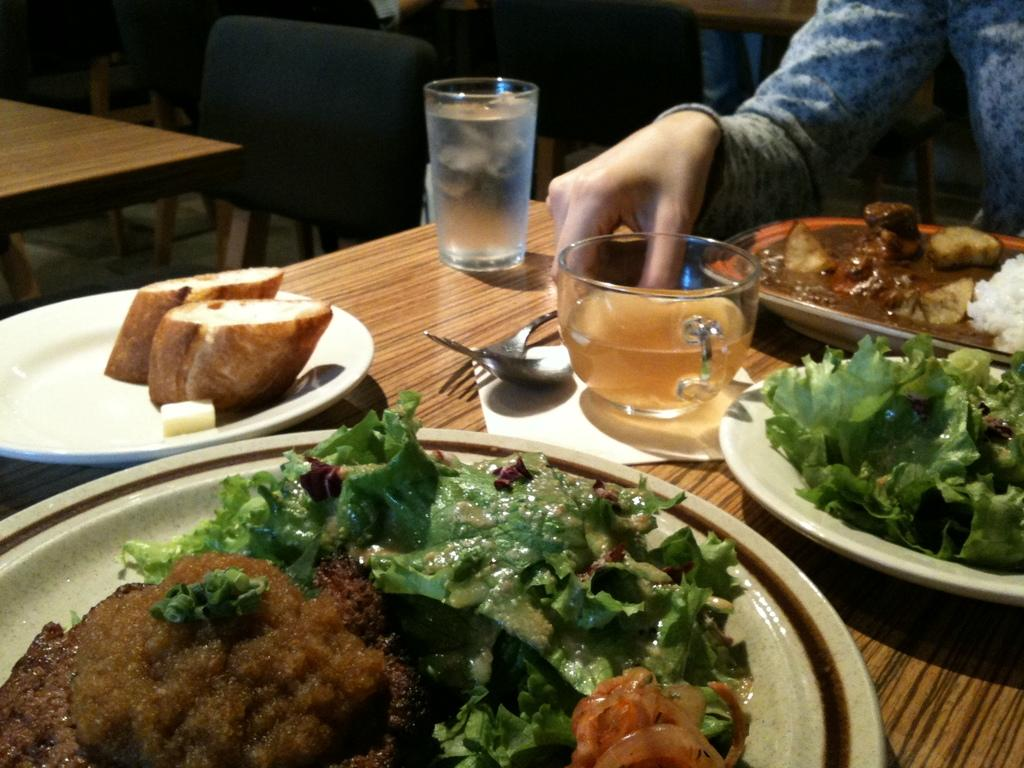What is the person in the image doing? The person is sitting behind a table in the image. What can be seen on the table in the image? There is food, a plate, a fork, a spoon, a glass, a cup, and a tissue on the table. How many utensils are present on the table? There are two utensils on the table: a fork and a spoon. How many cows are visible in the image? There are no cows present in the image. What book is the person reading in the image? There is no book visible in the image. 